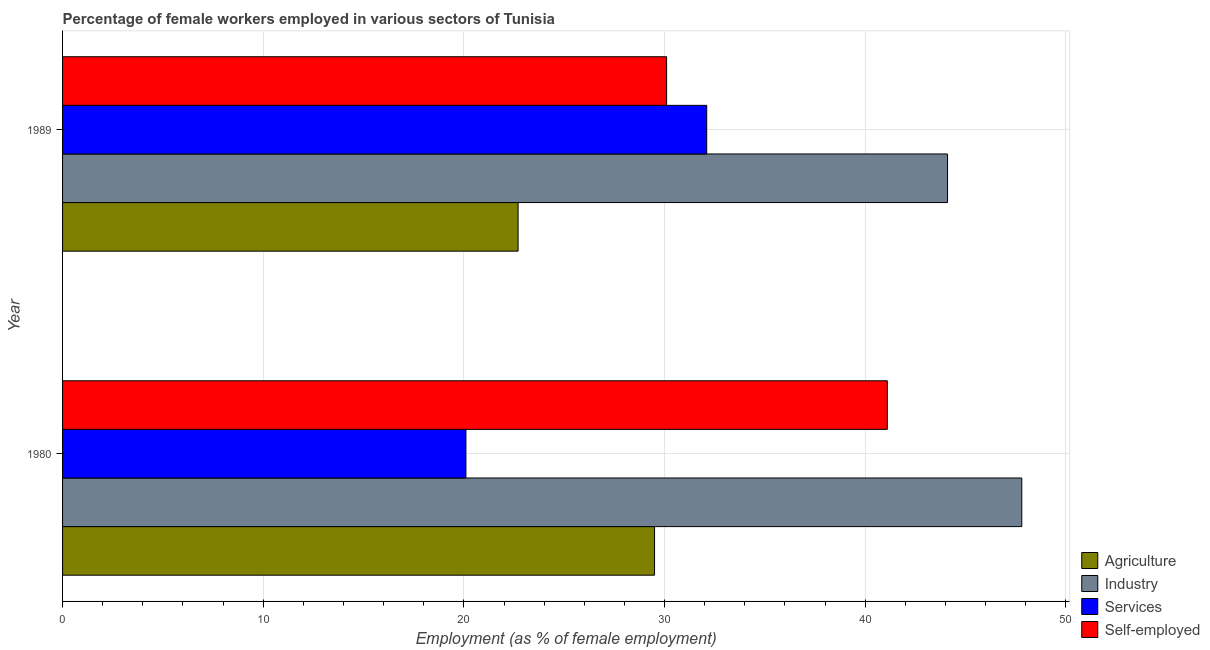Are the number of bars per tick equal to the number of legend labels?
Give a very brief answer. Yes. How many bars are there on the 2nd tick from the bottom?
Give a very brief answer. 4. What is the percentage of female workers in services in 1989?
Provide a succinct answer. 32.1. Across all years, what is the maximum percentage of female workers in industry?
Provide a succinct answer. 47.8. Across all years, what is the minimum percentage of self employed female workers?
Offer a very short reply. 30.1. What is the total percentage of female workers in industry in the graph?
Give a very brief answer. 91.9. What is the difference between the percentage of female workers in services in 1980 and the percentage of self employed female workers in 1989?
Provide a short and direct response. -10. What is the average percentage of self employed female workers per year?
Your answer should be compact. 35.6. In how many years, is the percentage of self employed female workers greater than 24 %?
Your answer should be very brief. 2. What is the ratio of the percentage of female workers in services in 1980 to that in 1989?
Your answer should be very brief. 0.63. Is it the case that in every year, the sum of the percentage of female workers in agriculture and percentage of self employed female workers is greater than the sum of percentage of female workers in industry and percentage of female workers in services?
Make the answer very short. Yes. What does the 1st bar from the top in 1989 represents?
Provide a short and direct response. Self-employed. What does the 3rd bar from the bottom in 1989 represents?
Offer a very short reply. Services. Is it the case that in every year, the sum of the percentage of female workers in agriculture and percentage of female workers in industry is greater than the percentage of female workers in services?
Make the answer very short. Yes. What is the difference between two consecutive major ticks on the X-axis?
Your response must be concise. 10. Are the values on the major ticks of X-axis written in scientific E-notation?
Ensure brevity in your answer.  No. Does the graph contain any zero values?
Your answer should be compact. No. How many legend labels are there?
Provide a succinct answer. 4. How are the legend labels stacked?
Your answer should be compact. Vertical. What is the title of the graph?
Ensure brevity in your answer.  Percentage of female workers employed in various sectors of Tunisia. What is the label or title of the X-axis?
Make the answer very short. Employment (as % of female employment). What is the Employment (as % of female employment) in Agriculture in 1980?
Make the answer very short. 29.5. What is the Employment (as % of female employment) in Industry in 1980?
Provide a short and direct response. 47.8. What is the Employment (as % of female employment) in Services in 1980?
Make the answer very short. 20.1. What is the Employment (as % of female employment) in Self-employed in 1980?
Make the answer very short. 41.1. What is the Employment (as % of female employment) of Agriculture in 1989?
Ensure brevity in your answer.  22.7. What is the Employment (as % of female employment) of Industry in 1989?
Provide a succinct answer. 44.1. What is the Employment (as % of female employment) in Services in 1989?
Keep it short and to the point. 32.1. What is the Employment (as % of female employment) in Self-employed in 1989?
Provide a succinct answer. 30.1. Across all years, what is the maximum Employment (as % of female employment) of Agriculture?
Give a very brief answer. 29.5. Across all years, what is the maximum Employment (as % of female employment) of Industry?
Your answer should be very brief. 47.8. Across all years, what is the maximum Employment (as % of female employment) in Services?
Make the answer very short. 32.1. Across all years, what is the maximum Employment (as % of female employment) in Self-employed?
Give a very brief answer. 41.1. Across all years, what is the minimum Employment (as % of female employment) of Agriculture?
Provide a short and direct response. 22.7. Across all years, what is the minimum Employment (as % of female employment) in Industry?
Keep it short and to the point. 44.1. Across all years, what is the minimum Employment (as % of female employment) in Services?
Your response must be concise. 20.1. Across all years, what is the minimum Employment (as % of female employment) in Self-employed?
Ensure brevity in your answer.  30.1. What is the total Employment (as % of female employment) in Agriculture in the graph?
Offer a very short reply. 52.2. What is the total Employment (as % of female employment) of Industry in the graph?
Give a very brief answer. 91.9. What is the total Employment (as % of female employment) of Services in the graph?
Your response must be concise. 52.2. What is the total Employment (as % of female employment) of Self-employed in the graph?
Provide a succinct answer. 71.2. What is the difference between the Employment (as % of female employment) in Agriculture in 1980 and the Employment (as % of female employment) in Industry in 1989?
Give a very brief answer. -14.6. What is the difference between the Employment (as % of female employment) of Agriculture in 1980 and the Employment (as % of female employment) of Services in 1989?
Provide a succinct answer. -2.6. What is the difference between the Employment (as % of female employment) of Agriculture in 1980 and the Employment (as % of female employment) of Self-employed in 1989?
Ensure brevity in your answer.  -0.6. What is the difference between the Employment (as % of female employment) in Services in 1980 and the Employment (as % of female employment) in Self-employed in 1989?
Give a very brief answer. -10. What is the average Employment (as % of female employment) of Agriculture per year?
Your response must be concise. 26.1. What is the average Employment (as % of female employment) in Industry per year?
Your response must be concise. 45.95. What is the average Employment (as % of female employment) in Services per year?
Your answer should be very brief. 26.1. What is the average Employment (as % of female employment) of Self-employed per year?
Keep it short and to the point. 35.6. In the year 1980, what is the difference between the Employment (as % of female employment) in Agriculture and Employment (as % of female employment) in Industry?
Provide a succinct answer. -18.3. In the year 1980, what is the difference between the Employment (as % of female employment) in Agriculture and Employment (as % of female employment) in Services?
Offer a very short reply. 9.4. In the year 1980, what is the difference between the Employment (as % of female employment) in Industry and Employment (as % of female employment) in Services?
Your answer should be very brief. 27.7. In the year 1980, what is the difference between the Employment (as % of female employment) of Industry and Employment (as % of female employment) of Self-employed?
Make the answer very short. 6.7. In the year 1989, what is the difference between the Employment (as % of female employment) of Agriculture and Employment (as % of female employment) of Industry?
Give a very brief answer. -21.4. In the year 1989, what is the difference between the Employment (as % of female employment) in Agriculture and Employment (as % of female employment) in Services?
Offer a terse response. -9.4. In the year 1989, what is the difference between the Employment (as % of female employment) in Industry and Employment (as % of female employment) in Services?
Your answer should be compact. 12. What is the ratio of the Employment (as % of female employment) of Agriculture in 1980 to that in 1989?
Your response must be concise. 1.3. What is the ratio of the Employment (as % of female employment) in Industry in 1980 to that in 1989?
Provide a short and direct response. 1.08. What is the ratio of the Employment (as % of female employment) in Services in 1980 to that in 1989?
Give a very brief answer. 0.63. What is the ratio of the Employment (as % of female employment) in Self-employed in 1980 to that in 1989?
Keep it short and to the point. 1.37. What is the difference between the highest and the second highest Employment (as % of female employment) in Industry?
Offer a terse response. 3.7. What is the difference between the highest and the second highest Employment (as % of female employment) of Services?
Keep it short and to the point. 12. What is the difference between the highest and the lowest Employment (as % of female employment) in Agriculture?
Your answer should be compact. 6.8. What is the difference between the highest and the lowest Employment (as % of female employment) in Self-employed?
Give a very brief answer. 11. 